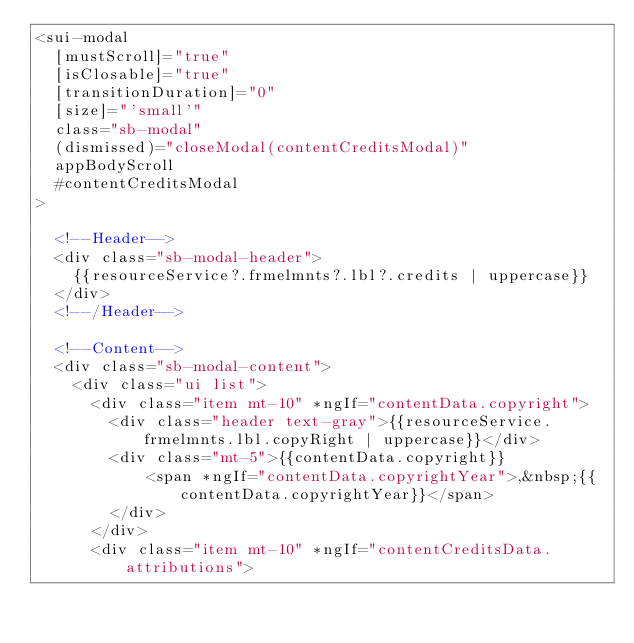Convert code to text. <code><loc_0><loc_0><loc_500><loc_500><_HTML_><sui-modal 
  [mustScroll]="true" 
  [isClosable]="true"
  [transitionDuration]="0"
  [size]="'small'"
  class="sb-modal"
  (dismissed)="closeModal(contentCreditsModal)"
  appBodyScroll
  #contentCreditsModal
>

  <!--Header-->
  <div class="sb-modal-header">
    {{resourceService?.frmelmnts?.lbl?.credits | uppercase}}
  </div>
  <!--/Header-->

  <!--Content-->
  <div class="sb-modal-content">
    <div class="ui list">
      <div class="item mt-10" *ngIf="contentData.copyright">
        <div class="header text-gray">{{resourceService.frmelmnts.lbl.copyRight | uppercase}}</div>
        <div class="mt-5">{{contentData.copyright}}
            <span *ngIf="contentData.copyrightYear">,&nbsp;{{contentData.copyrightYear}}</span>
        </div>
      </div>
      <div class="item mt-10" *ngIf="contentCreditsData.attributions"></code> 